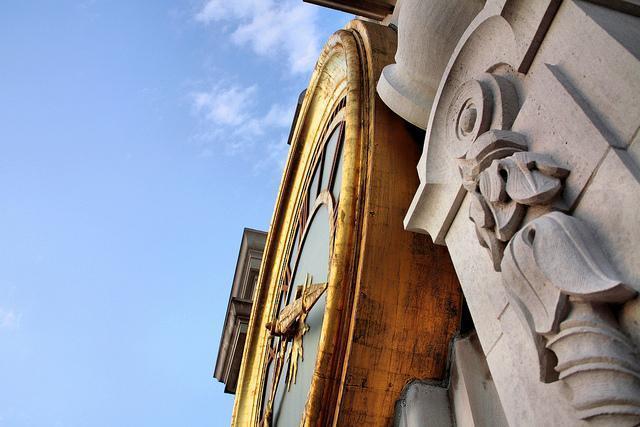How many people are swimming?
Give a very brief answer. 0. 